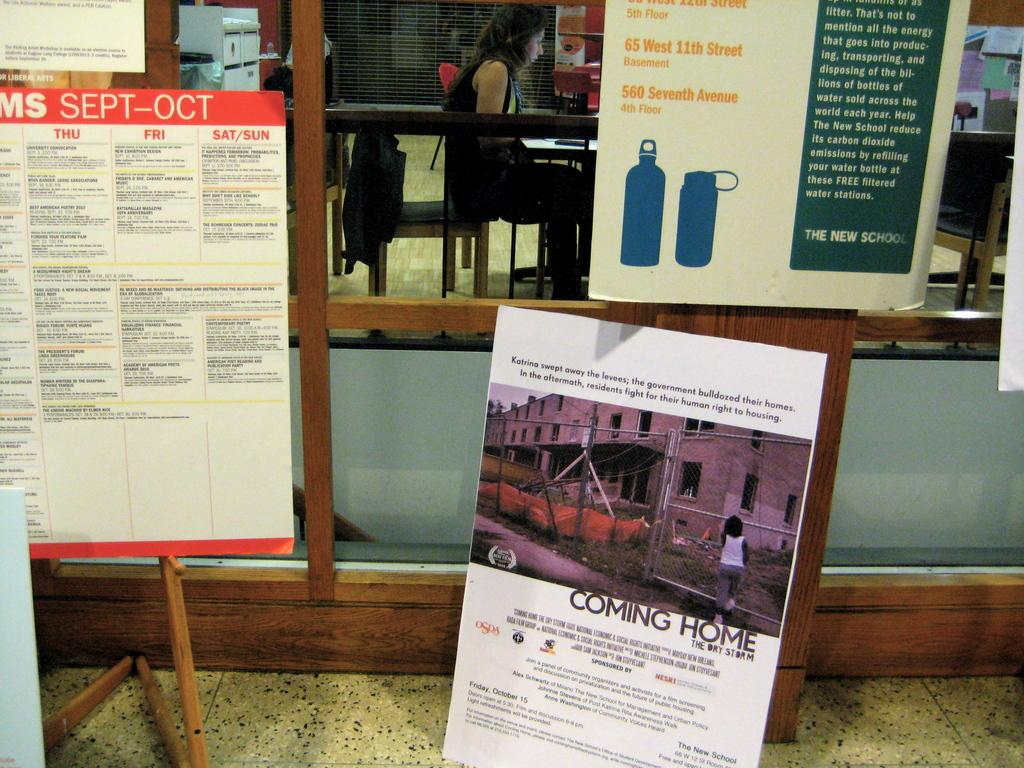<image>
Provide a brief description of the given image. Three posters are against the wall, one of which says coming home the dry storm. 